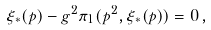Convert formula to latex. <formula><loc_0><loc_0><loc_500><loc_500>\xi _ { \ast } ( p ) - g ^ { 2 } \pi _ { 1 } ( p ^ { 2 } , \xi _ { \ast } ( p ) ) = 0 \, ,</formula> 